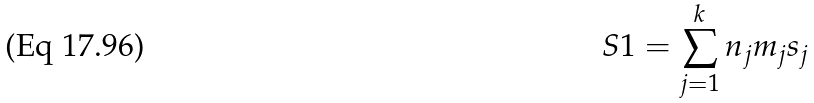<formula> <loc_0><loc_0><loc_500><loc_500>S 1 = \sum _ { j = 1 } ^ { k } n _ { j } m _ { j } s _ { j }</formula> 